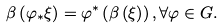Convert formula to latex. <formula><loc_0><loc_0><loc_500><loc_500>\beta \left ( \varphi _ { \ast } \xi \right ) = \varphi ^ { \ast } \left ( \beta \left ( \xi \right ) \right ) , \forall \varphi \in G .</formula> 